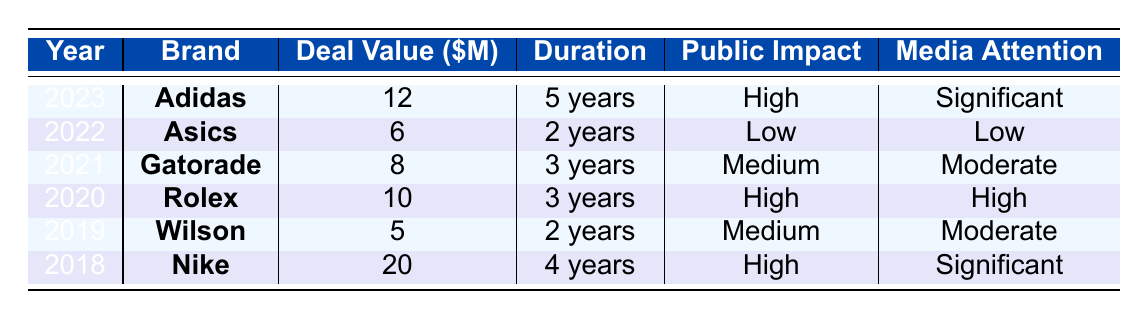What is the deal value for the sponsorship in 2021? The table shows the sponsorship deal for 2021 made with Gatorade, which has a deal value of 8 million USD.
Answer: 8 million Which brand had the highest deal value, and what was that value? The brand with the highest deal value is Nike in 2018, with a deal value of 20 million USD.
Answer: Nike, 20 million How many years was the sponsorship deal with Rolex, and what was its public impact? The table indicates that the deal with Rolex lasted for 3 years, and its public impact was categorized as high.
Answer: 3 years, high How does the average deal value from 2019 to 2023 compare to that of 2018? The average deal value from 2019 to 2023 is calculated by adding the deal values from those years (5 + 10 + 8 + 12) and dividing by the number of years (4), which yields 8.75 million. The deal value for 2018 is 20 million. Since 20 million is greater than 8.75 million, the 2018 deal value exceeds the average of the following years.
Answer: Higher than average Is it true that all sponsorships after 2018 had a deal value below 20 million? After 2018, each subsequent deal (from 2019 to 2023) had deal values of 5, 10, 8, 6, and 12 million, all of which are below 20 million. Therefore, the statement is true.
Answer: Yes What is the total deal value for 2020 and 2023 combined? The deal value for 2020 (Rolex) is 10 million and for 2023 (Adidas) is 12 million. Adding these gives 10 + 12 = 22 million.
Answer: 22 million 